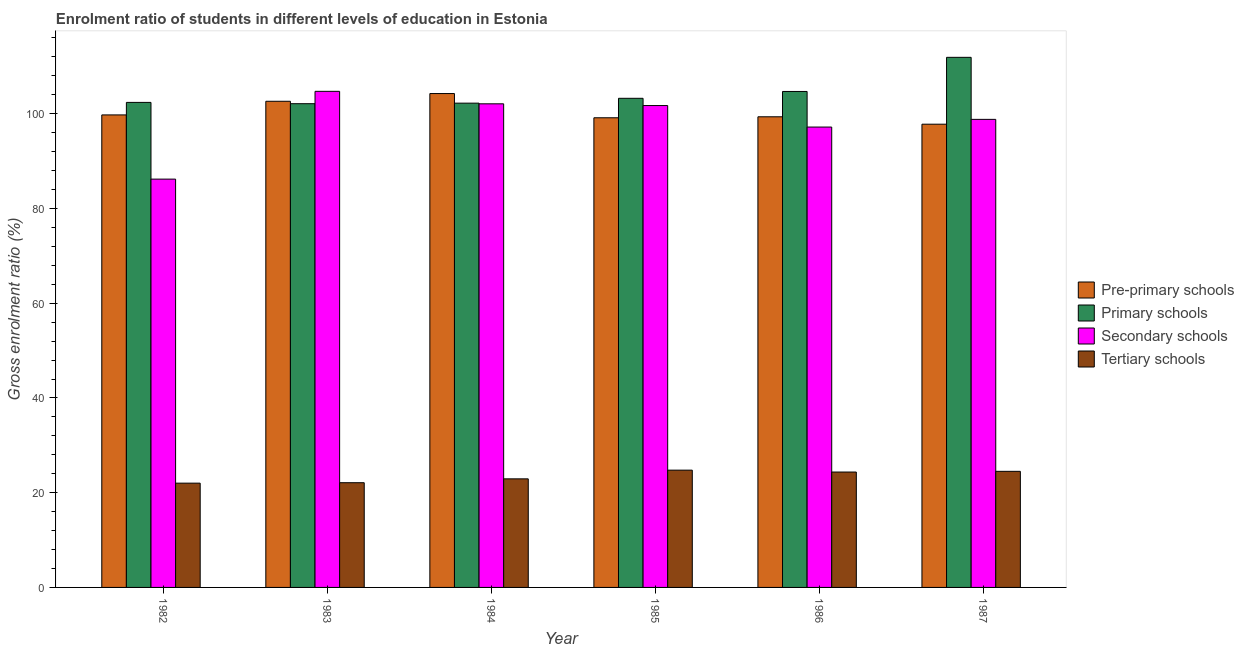Are the number of bars on each tick of the X-axis equal?
Provide a short and direct response. Yes. How many bars are there on the 5th tick from the left?
Offer a very short reply. 4. How many bars are there on the 1st tick from the right?
Your response must be concise. 4. In how many cases, is the number of bars for a given year not equal to the number of legend labels?
Offer a very short reply. 0. What is the gross enrolment ratio in tertiary schools in 1985?
Your answer should be very brief. 24.76. Across all years, what is the maximum gross enrolment ratio in primary schools?
Your response must be concise. 111.91. Across all years, what is the minimum gross enrolment ratio in primary schools?
Ensure brevity in your answer.  102.12. What is the total gross enrolment ratio in tertiary schools in the graph?
Provide a succinct answer. 140.67. What is the difference between the gross enrolment ratio in pre-primary schools in 1983 and that in 1986?
Your answer should be very brief. 3.27. What is the difference between the gross enrolment ratio in pre-primary schools in 1985 and the gross enrolment ratio in secondary schools in 1982?
Your answer should be very brief. -0.6. What is the average gross enrolment ratio in primary schools per year?
Make the answer very short. 104.44. In the year 1983, what is the difference between the gross enrolment ratio in tertiary schools and gross enrolment ratio in secondary schools?
Provide a short and direct response. 0. In how many years, is the gross enrolment ratio in pre-primary schools greater than 8 %?
Your answer should be compact. 6. What is the ratio of the gross enrolment ratio in primary schools in 1986 to that in 1987?
Ensure brevity in your answer.  0.94. Is the gross enrolment ratio in tertiary schools in 1983 less than that in 1985?
Offer a terse response. Yes. Is the difference between the gross enrolment ratio in primary schools in 1982 and 1983 greater than the difference between the gross enrolment ratio in pre-primary schools in 1982 and 1983?
Your answer should be compact. No. What is the difference between the highest and the second highest gross enrolment ratio in pre-primary schools?
Offer a very short reply. 1.63. What is the difference between the highest and the lowest gross enrolment ratio in secondary schools?
Offer a terse response. 18.53. Is the sum of the gross enrolment ratio in primary schools in 1984 and 1985 greater than the maximum gross enrolment ratio in tertiary schools across all years?
Your response must be concise. Yes. Is it the case that in every year, the sum of the gross enrolment ratio in secondary schools and gross enrolment ratio in tertiary schools is greater than the sum of gross enrolment ratio in pre-primary schools and gross enrolment ratio in primary schools?
Provide a short and direct response. No. What does the 4th bar from the left in 1983 represents?
Offer a terse response. Tertiary schools. What does the 4th bar from the right in 1983 represents?
Provide a short and direct response. Pre-primary schools. Is it the case that in every year, the sum of the gross enrolment ratio in pre-primary schools and gross enrolment ratio in primary schools is greater than the gross enrolment ratio in secondary schools?
Provide a succinct answer. Yes. How many bars are there?
Ensure brevity in your answer.  24. How many years are there in the graph?
Offer a very short reply. 6. What is the difference between two consecutive major ticks on the Y-axis?
Your response must be concise. 20. Are the values on the major ticks of Y-axis written in scientific E-notation?
Your answer should be compact. No. Does the graph contain grids?
Offer a very short reply. No. What is the title of the graph?
Ensure brevity in your answer.  Enrolment ratio of students in different levels of education in Estonia. What is the Gross enrolment ratio (%) of Pre-primary schools in 1982?
Offer a very short reply. 99.75. What is the Gross enrolment ratio (%) in Primary schools in 1982?
Provide a short and direct response. 102.39. What is the Gross enrolment ratio (%) of Secondary schools in 1982?
Give a very brief answer. 86.2. What is the Gross enrolment ratio (%) in Tertiary schools in 1982?
Your answer should be very brief. 22.01. What is the Gross enrolment ratio (%) in Pre-primary schools in 1983?
Ensure brevity in your answer.  102.63. What is the Gross enrolment ratio (%) in Primary schools in 1983?
Give a very brief answer. 102.12. What is the Gross enrolment ratio (%) of Secondary schools in 1983?
Provide a short and direct response. 104.73. What is the Gross enrolment ratio (%) in Tertiary schools in 1983?
Make the answer very short. 22.11. What is the Gross enrolment ratio (%) in Pre-primary schools in 1984?
Your answer should be very brief. 104.26. What is the Gross enrolment ratio (%) in Primary schools in 1984?
Offer a terse response. 102.24. What is the Gross enrolment ratio (%) in Secondary schools in 1984?
Offer a terse response. 102.1. What is the Gross enrolment ratio (%) of Tertiary schools in 1984?
Offer a very short reply. 22.92. What is the Gross enrolment ratio (%) in Pre-primary schools in 1985?
Provide a short and direct response. 99.15. What is the Gross enrolment ratio (%) in Primary schools in 1985?
Provide a short and direct response. 103.26. What is the Gross enrolment ratio (%) of Secondary schools in 1985?
Make the answer very short. 101.73. What is the Gross enrolment ratio (%) in Tertiary schools in 1985?
Your answer should be very brief. 24.76. What is the Gross enrolment ratio (%) in Pre-primary schools in 1986?
Offer a terse response. 99.36. What is the Gross enrolment ratio (%) of Primary schools in 1986?
Your response must be concise. 104.7. What is the Gross enrolment ratio (%) in Secondary schools in 1986?
Offer a very short reply. 97.19. What is the Gross enrolment ratio (%) of Tertiary schools in 1986?
Offer a terse response. 24.36. What is the Gross enrolment ratio (%) in Pre-primary schools in 1987?
Offer a very short reply. 97.79. What is the Gross enrolment ratio (%) of Primary schools in 1987?
Keep it short and to the point. 111.91. What is the Gross enrolment ratio (%) in Secondary schools in 1987?
Your response must be concise. 98.81. What is the Gross enrolment ratio (%) of Tertiary schools in 1987?
Keep it short and to the point. 24.51. Across all years, what is the maximum Gross enrolment ratio (%) of Pre-primary schools?
Your answer should be compact. 104.26. Across all years, what is the maximum Gross enrolment ratio (%) of Primary schools?
Make the answer very short. 111.91. Across all years, what is the maximum Gross enrolment ratio (%) of Secondary schools?
Keep it short and to the point. 104.73. Across all years, what is the maximum Gross enrolment ratio (%) of Tertiary schools?
Provide a short and direct response. 24.76. Across all years, what is the minimum Gross enrolment ratio (%) of Pre-primary schools?
Give a very brief answer. 97.79. Across all years, what is the minimum Gross enrolment ratio (%) in Primary schools?
Provide a succinct answer. 102.12. Across all years, what is the minimum Gross enrolment ratio (%) of Secondary schools?
Your answer should be very brief. 86.2. Across all years, what is the minimum Gross enrolment ratio (%) of Tertiary schools?
Give a very brief answer. 22.01. What is the total Gross enrolment ratio (%) in Pre-primary schools in the graph?
Make the answer very short. 602.95. What is the total Gross enrolment ratio (%) in Primary schools in the graph?
Provide a succinct answer. 626.62. What is the total Gross enrolment ratio (%) of Secondary schools in the graph?
Make the answer very short. 590.75. What is the total Gross enrolment ratio (%) in Tertiary schools in the graph?
Ensure brevity in your answer.  140.67. What is the difference between the Gross enrolment ratio (%) of Pre-primary schools in 1982 and that in 1983?
Ensure brevity in your answer.  -2.88. What is the difference between the Gross enrolment ratio (%) in Primary schools in 1982 and that in 1983?
Your response must be concise. 0.28. What is the difference between the Gross enrolment ratio (%) of Secondary schools in 1982 and that in 1983?
Your response must be concise. -18.53. What is the difference between the Gross enrolment ratio (%) of Tertiary schools in 1982 and that in 1983?
Your response must be concise. -0.09. What is the difference between the Gross enrolment ratio (%) of Pre-primary schools in 1982 and that in 1984?
Ensure brevity in your answer.  -4.51. What is the difference between the Gross enrolment ratio (%) of Primary schools in 1982 and that in 1984?
Keep it short and to the point. 0.16. What is the difference between the Gross enrolment ratio (%) in Secondary schools in 1982 and that in 1984?
Offer a terse response. -15.9. What is the difference between the Gross enrolment ratio (%) of Tertiary schools in 1982 and that in 1984?
Offer a very short reply. -0.91. What is the difference between the Gross enrolment ratio (%) in Pre-primary schools in 1982 and that in 1985?
Provide a succinct answer. 0.6. What is the difference between the Gross enrolment ratio (%) of Primary schools in 1982 and that in 1985?
Keep it short and to the point. -0.87. What is the difference between the Gross enrolment ratio (%) of Secondary schools in 1982 and that in 1985?
Your answer should be compact. -15.53. What is the difference between the Gross enrolment ratio (%) of Tertiary schools in 1982 and that in 1985?
Offer a terse response. -2.75. What is the difference between the Gross enrolment ratio (%) in Pre-primary schools in 1982 and that in 1986?
Your answer should be very brief. 0.4. What is the difference between the Gross enrolment ratio (%) in Primary schools in 1982 and that in 1986?
Give a very brief answer. -2.31. What is the difference between the Gross enrolment ratio (%) of Secondary schools in 1982 and that in 1986?
Keep it short and to the point. -10.99. What is the difference between the Gross enrolment ratio (%) of Tertiary schools in 1982 and that in 1986?
Provide a succinct answer. -2.35. What is the difference between the Gross enrolment ratio (%) of Pre-primary schools in 1982 and that in 1987?
Make the answer very short. 1.96. What is the difference between the Gross enrolment ratio (%) of Primary schools in 1982 and that in 1987?
Your answer should be very brief. -9.51. What is the difference between the Gross enrolment ratio (%) in Secondary schools in 1982 and that in 1987?
Keep it short and to the point. -12.61. What is the difference between the Gross enrolment ratio (%) of Tertiary schools in 1982 and that in 1987?
Give a very brief answer. -2.49. What is the difference between the Gross enrolment ratio (%) of Pre-primary schools in 1983 and that in 1984?
Keep it short and to the point. -1.63. What is the difference between the Gross enrolment ratio (%) in Primary schools in 1983 and that in 1984?
Give a very brief answer. -0.12. What is the difference between the Gross enrolment ratio (%) in Secondary schools in 1983 and that in 1984?
Provide a succinct answer. 2.63. What is the difference between the Gross enrolment ratio (%) of Tertiary schools in 1983 and that in 1984?
Offer a very short reply. -0.81. What is the difference between the Gross enrolment ratio (%) of Pre-primary schools in 1983 and that in 1985?
Your answer should be compact. 3.48. What is the difference between the Gross enrolment ratio (%) of Primary schools in 1983 and that in 1985?
Your answer should be compact. -1.14. What is the difference between the Gross enrolment ratio (%) in Secondary schools in 1983 and that in 1985?
Offer a very short reply. 3. What is the difference between the Gross enrolment ratio (%) in Tertiary schools in 1983 and that in 1985?
Offer a very short reply. -2.65. What is the difference between the Gross enrolment ratio (%) of Pre-primary schools in 1983 and that in 1986?
Give a very brief answer. 3.27. What is the difference between the Gross enrolment ratio (%) of Primary schools in 1983 and that in 1986?
Provide a short and direct response. -2.58. What is the difference between the Gross enrolment ratio (%) of Secondary schools in 1983 and that in 1986?
Keep it short and to the point. 7.54. What is the difference between the Gross enrolment ratio (%) in Tertiary schools in 1983 and that in 1986?
Ensure brevity in your answer.  -2.25. What is the difference between the Gross enrolment ratio (%) in Pre-primary schools in 1983 and that in 1987?
Keep it short and to the point. 4.84. What is the difference between the Gross enrolment ratio (%) in Primary schools in 1983 and that in 1987?
Ensure brevity in your answer.  -9.79. What is the difference between the Gross enrolment ratio (%) of Secondary schools in 1983 and that in 1987?
Keep it short and to the point. 5.92. What is the difference between the Gross enrolment ratio (%) in Tertiary schools in 1983 and that in 1987?
Offer a very short reply. -2.4. What is the difference between the Gross enrolment ratio (%) in Pre-primary schools in 1984 and that in 1985?
Keep it short and to the point. 5.11. What is the difference between the Gross enrolment ratio (%) of Primary schools in 1984 and that in 1985?
Provide a succinct answer. -1.02. What is the difference between the Gross enrolment ratio (%) of Secondary schools in 1984 and that in 1985?
Your response must be concise. 0.37. What is the difference between the Gross enrolment ratio (%) in Tertiary schools in 1984 and that in 1985?
Ensure brevity in your answer.  -1.84. What is the difference between the Gross enrolment ratio (%) in Pre-primary schools in 1984 and that in 1986?
Make the answer very short. 4.9. What is the difference between the Gross enrolment ratio (%) of Primary schools in 1984 and that in 1986?
Make the answer very short. -2.47. What is the difference between the Gross enrolment ratio (%) of Secondary schools in 1984 and that in 1986?
Ensure brevity in your answer.  4.91. What is the difference between the Gross enrolment ratio (%) in Tertiary schools in 1984 and that in 1986?
Offer a terse response. -1.44. What is the difference between the Gross enrolment ratio (%) of Pre-primary schools in 1984 and that in 1987?
Your answer should be very brief. 6.47. What is the difference between the Gross enrolment ratio (%) of Primary schools in 1984 and that in 1987?
Make the answer very short. -9.67. What is the difference between the Gross enrolment ratio (%) in Secondary schools in 1984 and that in 1987?
Your response must be concise. 3.28. What is the difference between the Gross enrolment ratio (%) in Tertiary schools in 1984 and that in 1987?
Keep it short and to the point. -1.58. What is the difference between the Gross enrolment ratio (%) of Pre-primary schools in 1985 and that in 1986?
Your answer should be compact. -0.21. What is the difference between the Gross enrolment ratio (%) in Primary schools in 1985 and that in 1986?
Offer a terse response. -1.44. What is the difference between the Gross enrolment ratio (%) of Secondary schools in 1985 and that in 1986?
Make the answer very short. 4.54. What is the difference between the Gross enrolment ratio (%) in Tertiary schools in 1985 and that in 1986?
Ensure brevity in your answer.  0.4. What is the difference between the Gross enrolment ratio (%) in Pre-primary schools in 1985 and that in 1987?
Give a very brief answer. 1.36. What is the difference between the Gross enrolment ratio (%) in Primary schools in 1985 and that in 1987?
Provide a short and direct response. -8.65. What is the difference between the Gross enrolment ratio (%) in Secondary schools in 1985 and that in 1987?
Ensure brevity in your answer.  2.92. What is the difference between the Gross enrolment ratio (%) of Tertiary schools in 1985 and that in 1987?
Your answer should be compact. 0.25. What is the difference between the Gross enrolment ratio (%) in Pre-primary schools in 1986 and that in 1987?
Your response must be concise. 1.56. What is the difference between the Gross enrolment ratio (%) in Primary schools in 1986 and that in 1987?
Your response must be concise. -7.21. What is the difference between the Gross enrolment ratio (%) of Secondary schools in 1986 and that in 1987?
Provide a succinct answer. -1.62. What is the difference between the Gross enrolment ratio (%) in Tertiary schools in 1986 and that in 1987?
Offer a terse response. -0.15. What is the difference between the Gross enrolment ratio (%) of Pre-primary schools in 1982 and the Gross enrolment ratio (%) of Primary schools in 1983?
Ensure brevity in your answer.  -2.37. What is the difference between the Gross enrolment ratio (%) of Pre-primary schools in 1982 and the Gross enrolment ratio (%) of Secondary schools in 1983?
Your answer should be very brief. -4.98. What is the difference between the Gross enrolment ratio (%) in Pre-primary schools in 1982 and the Gross enrolment ratio (%) in Tertiary schools in 1983?
Your answer should be very brief. 77.65. What is the difference between the Gross enrolment ratio (%) of Primary schools in 1982 and the Gross enrolment ratio (%) of Secondary schools in 1983?
Offer a terse response. -2.34. What is the difference between the Gross enrolment ratio (%) of Primary schools in 1982 and the Gross enrolment ratio (%) of Tertiary schools in 1983?
Your response must be concise. 80.29. What is the difference between the Gross enrolment ratio (%) in Secondary schools in 1982 and the Gross enrolment ratio (%) in Tertiary schools in 1983?
Provide a short and direct response. 64.09. What is the difference between the Gross enrolment ratio (%) of Pre-primary schools in 1982 and the Gross enrolment ratio (%) of Primary schools in 1984?
Provide a succinct answer. -2.48. What is the difference between the Gross enrolment ratio (%) of Pre-primary schools in 1982 and the Gross enrolment ratio (%) of Secondary schools in 1984?
Keep it short and to the point. -2.34. What is the difference between the Gross enrolment ratio (%) in Pre-primary schools in 1982 and the Gross enrolment ratio (%) in Tertiary schools in 1984?
Your answer should be very brief. 76.83. What is the difference between the Gross enrolment ratio (%) in Primary schools in 1982 and the Gross enrolment ratio (%) in Secondary schools in 1984?
Offer a very short reply. 0.3. What is the difference between the Gross enrolment ratio (%) of Primary schools in 1982 and the Gross enrolment ratio (%) of Tertiary schools in 1984?
Make the answer very short. 79.47. What is the difference between the Gross enrolment ratio (%) of Secondary schools in 1982 and the Gross enrolment ratio (%) of Tertiary schools in 1984?
Provide a short and direct response. 63.27. What is the difference between the Gross enrolment ratio (%) in Pre-primary schools in 1982 and the Gross enrolment ratio (%) in Primary schools in 1985?
Give a very brief answer. -3.51. What is the difference between the Gross enrolment ratio (%) in Pre-primary schools in 1982 and the Gross enrolment ratio (%) in Secondary schools in 1985?
Provide a succinct answer. -1.97. What is the difference between the Gross enrolment ratio (%) in Pre-primary schools in 1982 and the Gross enrolment ratio (%) in Tertiary schools in 1985?
Ensure brevity in your answer.  74.99. What is the difference between the Gross enrolment ratio (%) in Primary schools in 1982 and the Gross enrolment ratio (%) in Secondary schools in 1985?
Your answer should be compact. 0.67. What is the difference between the Gross enrolment ratio (%) in Primary schools in 1982 and the Gross enrolment ratio (%) in Tertiary schools in 1985?
Give a very brief answer. 77.63. What is the difference between the Gross enrolment ratio (%) of Secondary schools in 1982 and the Gross enrolment ratio (%) of Tertiary schools in 1985?
Offer a very short reply. 61.44. What is the difference between the Gross enrolment ratio (%) of Pre-primary schools in 1982 and the Gross enrolment ratio (%) of Primary schools in 1986?
Provide a short and direct response. -4.95. What is the difference between the Gross enrolment ratio (%) of Pre-primary schools in 1982 and the Gross enrolment ratio (%) of Secondary schools in 1986?
Ensure brevity in your answer.  2.56. What is the difference between the Gross enrolment ratio (%) of Pre-primary schools in 1982 and the Gross enrolment ratio (%) of Tertiary schools in 1986?
Provide a short and direct response. 75.39. What is the difference between the Gross enrolment ratio (%) in Primary schools in 1982 and the Gross enrolment ratio (%) in Secondary schools in 1986?
Keep it short and to the point. 5.2. What is the difference between the Gross enrolment ratio (%) in Primary schools in 1982 and the Gross enrolment ratio (%) in Tertiary schools in 1986?
Your answer should be compact. 78.04. What is the difference between the Gross enrolment ratio (%) of Secondary schools in 1982 and the Gross enrolment ratio (%) of Tertiary schools in 1986?
Your answer should be very brief. 61.84. What is the difference between the Gross enrolment ratio (%) in Pre-primary schools in 1982 and the Gross enrolment ratio (%) in Primary schools in 1987?
Your response must be concise. -12.16. What is the difference between the Gross enrolment ratio (%) in Pre-primary schools in 1982 and the Gross enrolment ratio (%) in Secondary schools in 1987?
Offer a very short reply. 0.94. What is the difference between the Gross enrolment ratio (%) in Pre-primary schools in 1982 and the Gross enrolment ratio (%) in Tertiary schools in 1987?
Make the answer very short. 75.25. What is the difference between the Gross enrolment ratio (%) in Primary schools in 1982 and the Gross enrolment ratio (%) in Secondary schools in 1987?
Keep it short and to the point. 3.58. What is the difference between the Gross enrolment ratio (%) of Primary schools in 1982 and the Gross enrolment ratio (%) of Tertiary schools in 1987?
Offer a very short reply. 77.89. What is the difference between the Gross enrolment ratio (%) in Secondary schools in 1982 and the Gross enrolment ratio (%) in Tertiary schools in 1987?
Your answer should be compact. 61.69. What is the difference between the Gross enrolment ratio (%) of Pre-primary schools in 1983 and the Gross enrolment ratio (%) of Primary schools in 1984?
Ensure brevity in your answer.  0.4. What is the difference between the Gross enrolment ratio (%) of Pre-primary schools in 1983 and the Gross enrolment ratio (%) of Secondary schools in 1984?
Your answer should be very brief. 0.54. What is the difference between the Gross enrolment ratio (%) in Pre-primary schools in 1983 and the Gross enrolment ratio (%) in Tertiary schools in 1984?
Ensure brevity in your answer.  79.71. What is the difference between the Gross enrolment ratio (%) in Primary schools in 1983 and the Gross enrolment ratio (%) in Secondary schools in 1984?
Provide a succinct answer. 0.02. What is the difference between the Gross enrolment ratio (%) of Primary schools in 1983 and the Gross enrolment ratio (%) of Tertiary schools in 1984?
Give a very brief answer. 79.2. What is the difference between the Gross enrolment ratio (%) of Secondary schools in 1983 and the Gross enrolment ratio (%) of Tertiary schools in 1984?
Make the answer very short. 81.81. What is the difference between the Gross enrolment ratio (%) of Pre-primary schools in 1983 and the Gross enrolment ratio (%) of Primary schools in 1985?
Make the answer very short. -0.63. What is the difference between the Gross enrolment ratio (%) in Pre-primary schools in 1983 and the Gross enrolment ratio (%) in Secondary schools in 1985?
Provide a short and direct response. 0.9. What is the difference between the Gross enrolment ratio (%) in Pre-primary schools in 1983 and the Gross enrolment ratio (%) in Tertiary schools in 1985?
Your answer should be very brief. 77.87. What is the difference between the Gross enrolment ratio (%) of Primary schools in 1983 and the Gross enrolment ratio (%) of Secondary schools in 1985?
Offer a very short reply. 0.39. What is the difference between the Gross enrolment ratio (%) in Primary schools in 1983 and the Gross enrolment ratio (%) in Tertiary schools in 1985?
Provide a short and direct response. 77.36. What is the difference between the Gross enrolment ratio (%) in Secondary schools in 1983 and the Gross enrolment ratio (%) in Tertiary schools in 1985?
Keep it short and to the point. 79.97. What is the difference between the Gross enrolment ratio (%) in Pre-primary schools in 1983 and the Gross enrolment ratio (%) in Primary schools in 1986?
Your answer should be compact. -2.07. What is the difference between the Gross enrolment ratio (%) in Pre-primary schools in 1983 and the Gross enrolment ratio (%) in Secondary schools in 1986?
Keep it short and to the point. 5.44. What is the difference between the Gross enrolment ratio (%) of Pre-primary schools in 1983 and the Gross enrolment ratio (%) of Tertiary schools in 1986?
Give a very brief answer. 78.27. What is the difference between the Gross enrolment ratio (%) of Primary schools in 1983 and the Gross enrolment ratio (%) of Secondary schools in 1986?
Ensure brevity in your answer.  4.93. What is the difference between the Gross enrolment ratio (%) of Primary schools in 1983 and the Gross enrolment ratio (%) of Tertiary schools in 1986?
Keep it short and to the point. 77.76. What is the difference between the Gross enrolment ratio (%) in Secondary schools in 1983 and the Gross enrolment ratio (%) in Tertiary schools in 1986?
Your answer should be very brief. 80.37. What is the difference between the Gross enrolment ratio (%) in Pre-primary schools in 1983 and the Gross enrolment ratio (%) in Primary schools in 1987?
Provide a succinct answer. -9.28. What is the difference between the Gross enrolment ratio (%) in Pre-primary schools in 1983 and the Gross enrolment ratio (%) in Secondary schools in 1987?
Offer a very short reply. 3.82. What is the difference between the Gross enrolment ratio (%) in Pre-primary schools in 1983 and the Gross enrolment ratio (%) in Tertiary schools in 1987?
Offer a very short reply. 78.12. What is the difference between the Gross enrolment ratio (%) in Primary schools in 1983 and the Gross enrolment ratio (%) in Secondary schools in 1987?
Keep it short and to the point. 3.31. What is the difference between the Gross enrolment ratio (%) of Primary schools in 1983 and the Gross enrolment ratio (%) of Tertiary schools in 1987?
Your response must be concise. 77.61. What is the difference between the Gross enrolment ratio (%) of Secondary schools in 1983 and the Gross enrolment ratio (%) of Tertiary schools in 1987?
Your answer should be very brief. 80.22. What is the difference between the Gross enrolment ratio (%) in Pre-primary schools in 1984 and the Gross enrolment ratio (%) in Primary schools in 1985?
Provide a succinct answer. 1. What is the difference between the Gross enrolment ratio (%) of Pre-primary schools in 1984 and the Gross enrolment ratio (%) of Secondary schools in 1985?
Your answer should be very brief. 2.53. What is the difference between the Gross enrolment ratio (%) of Pre-primary schools in 1984 and the Gross enrolment ratio (%) of Tertiary schools in 1985?
Provide a short and direct response. 79.5. What is the difference between the Gross enrolment ratio (%) in Primary schools in 1984 and the Gross enrolment ratio (%) in Secondary schools in 1985?
Offer a terse response. 0.51. What is the difference between the Gross enrolment ratio (%) in Primary schools in 1984 and the Gross enrolment ratio (%) in Tertiary schools in 1985?
Offer a terse response. 77.48. What is the difference between the Gross enrolment ratio (%) of Secondary schools in 1984 and the Gross enrolment ratio (%) of Tertiary schools in 1985?
Give a very brief answer. 77.34. What is the difference between the Gross enrolment ratio (%) in Pre-primary schools in 1984 and the Gross enrolment ratio (%) in Primary schools in 1986?
Make the answer very short. -0.44. What is the difference between the Gross enrolment ratio (%) in Pre-primary schools in 1984 and the Gross enrolment ratio (%) in Secondary schools in 1986?
Give a very brief answer. 7.07. What is the difference between the Gross enrolment ratio (%) of Pre-primary schools in 1984 and the Gross enrolment ratio (%) of Tertiary schools in 1986?
Your answer should be very brief. 79.9. What is the difference between the Gross enrolment ratio (%) in Primary schools in 1984 and the Gross enrolment ratio (%) in Secondary schools in 1986?
Your response must be concise. 5.04. What is the difference between the Gross enrolment ratio (%) of Primary schools in 1984 and the Gross enrolment ratio (%) of Tertiary schools in 1986?
Provide a succinct answer. 77.88. What is the difference between the Gross enrolment ratio (%) of Secondary schools in 1984 and the Gross enrolment ratio (%) of Tertiary schools in 1986?
Offer a very short reply. 77.74. What is the difference between the Gross enrolment ratio (%) of Pre-primary schools in 1984 and the Gross enrolment ratio (%) of Primary schools in 1987?
Your response must be concise. -7.65. What is the difference between the Gross enrolment ratio (%) in Pre-primary schools in 1984 and the Gross enrolment ratio (%) in Secondary schools in 1987?
Offer a terse response. 5.45. What is the difference between the Gross enrolment ratio (%) in Pre-primary schools in 1984 and the Gross enrolment ratio (%) in Tertiary schools in 1987?
Offer a very short reply. 79.75. What is the difference between the Gross enrolment ratio (%) in Primary schools in 1984 and the Gross enrolment ratio (%) in Secondary schools in 1987?
Provide a succinct answer. 3.42. What is the difference between the Gross enrolment ratio (%) of Primary schools in 1984 and the Gross enrolment ratio (%) of Tertiary schools in 1987?
Keep it short and to the point. 77.73. What is the difference between the Gross enrolment ratio (%) of Secondary schools in 1984 and the Gross enrolment ratio (%) of Tertiary schools in 1987?
Your response must be concise. 77.59. What is the difference between the Gross enrolment ratio (%) of Pre-primary schools in 1985 and the Gross enrolment ratio (%) of Primary schools in 1986?
Give a very brief answer. -5.55. What is the difference between the Gross enrolment ratio (%) in Pre-primary schools in 1985 and the Gross enrolment ratio (%) in Secondary schools in 1986?
Make the answer very short. 1.96. What is the difference between the Gross enrolment ratio (%) of Pre-primary schools in 1985 and the Gross enrolment ratio (%) of Tertiary schools in 1986?
Your answer should be compact. 74.79. What is the difference between the Gross enrolment ratio (%) of Primary schools in 1985 and the Gross enrolment ratio (%) of Secondary schools in 1986?
Ensure brevity in your answer.  6.07. What is the difference between the Gross enrolment ratio (%) of Primary schools in 1985 and the Gross enrolment ratio (%) of Tertiary schools in 1986?
Provide a short and direct response. 78.9. What is the difference between the Gross enrolment ratio (%) in Secondary schools in 1985 and the Gross enrolment ratio (%) in Tertiary schools in 1986?
Your answer should be very brief. 77.37. What is the difference between the Gross enrolment ratio (%) of Pre-primary schools in 1985 and the Gross enrolment ratio (%) of Primary schools in 1987?
Offer a very short reply. -12.76. What is the difference between the Gross enrolment ratio (%) in Pre-primary schools in 1985 and the Gross enrolment ratio (%) in Secondary schools in 1987?
Offer a very short reply. 0.34. What is the difference between the Gross enrolment ratio (%) in Pre-primary schools in 1985 and the Gross enrolment ratio (%) in Tertiary schools in 1987?
Your answer should be very brief. 74.64. What is the difference between the Gross enrolment ratio (%) in Primary schools in 1985 and the Gross enrolment ratio (%) in Secondary schools in 1987?
Provide a short and direct response. 4.45. What is the difference between the Gross enrolment ratio (%) in Primary schools in 1985 and the Gross enrolment ratio (%) in Tertiary schools in 1987?
Provide a short and direct response. 78.75. What is the difference between the Gross enrolment ratio (%) of Secondary schools in 1985 and the Gross enrolment ratio (%) of Tertiary schools in 1987?
Provide a short and direct response. 77.22. What is the difference between the Gross enrolment ratio (%) in Pre-primary schools in 1986 and the Gross enrolment ratio (%) in Primary schools in 1987?
Your answer should be very brief. -12.55. What is the difference between the Gross enrolment ratio (%) in Pre-primary schools in 1986 and the Gross enrolment ratio (%) in Secondary schools in 1987?
Offer a terse response. 0.55. What is the difference between the Gross enrolment ratio (%) in Pre-primary schools in 1986 and the Gross enrolment ratio (%) in Tertiary schools in 1987?
Offer a terse response. 74.85. What is the difference between the Gross enrolment ratio (%) in Primary schools in 1986 and the Gross enrolment ratio (%) in Secondary schools in 1987?
Provide a succinct answer. 5.89. What is the difference between the Gross enrolment ratio (%) in Primary schools in 1986 and the Gross enrolment ratio (%) in Tertiary schools in 1987?
Your response must be concise. 80.2. What is the difference between the Gross enrolment ratio (%) of Secondary schools in 1986 and the Gross enrolment ratio (%) of Tertiary schools in 1987?
Ensure brevity in your answer.  72.68. What is the average Gross enrolment ratio (%) of Pre-primary schools per year?
Provide a short and direct response. 100.49. What is the average Gross enrolment ratio (%) in Primary schools per year?
Your answer should be compact. 104.44. What is the average Gross enrolment ratio (%) of Secondary schools per year?
Your answer should be compact. 98.46. What is the average Gross enrolment ratio (%) in Tertiary schools per year?
Offer a terse response. 23.44. In the year 1982, what is the difference between the Gross enrolment ratio (%) of Pre-primary schools and Gross enrolment ratio (%) of Primary schools?
Make the answer very short. -2.64. In the year 1982, what is the difference between the Gross enrolment ratio (%) of Pre-primary schools and Gross enrolment ratio (%) of Secondary schools?
Ensure brevity in your answer.  13.56. In the year 1982, what is the difference between the Gross enrolment ratio (%) in Pre-primary schools and Gross enrolment ratio (%) in Tertiary schools?
Your response must be concise. 77.74. In the year 1982, what is the difference between the Gross enrolment ratio (%) in Primary schools and Gross enrolment ratio (%) in Secondary schools?
Offer a terse response. 16.2. In the year 1982, what is the difference between the Gross enrolment ratio (%) in Primary schools and Gross enrolment ratio (%) in Tertiary schools?
Your response must be concise. 80.38. In the year 1982, what is the difference between the Gross enrolment ratio (%) in Secondary schools and Gross enrolment ratio (%) in Tertiary schools?
Offer a very short reply. 64.18. In the year 1983, what is the difference between the Gross enrolment ratio (%) in Pre-primary schools and Gross enrolment ratio (%) in Primary schools?
Provide a short and direct response. 0.51. In the year 1983, what is the difference between the Gross enrolment ratio (%) in Pre-primary schools and Gross enrolment ratio (%) in Secondary schools?
Give a very brief answer. -2.1. In the year 1983, what is the difference between the Gross enrolment ratio (%) of Pre-primary schools and Gross enrolment ratio (%) of Tertiary schools?
Your answer should be very brief. 80.52. In the year 1983, what is the difference between the Gross enrolment ratio (%) of Primary schools and Gross enrolment ratio (%) of Secondary schools?
Your answer should be compact. -2.61. In the year 1983, what is the difference between the Gross enrolment ratio (%) of Primary schools and Gross enrolment ratio (%) of Tertiary schools?
Your answer should be very brief. 80.01. In the year 1983, what is the difference between the Gross enrolment ratio (%) in Secondary schools and Gross enrolment ratio (%) in Tertiary schools?
Give a very brief answer. 82.62. In the year 1984, what is the difference between the Gross enrolment ratio (%) of Pre-primary schools and Gross enrolment ratio (%) of Primary schools?
Offer a very short reply. 2.02. In the year 1984, what is the difference between the Gross enrolment ratio (%) of Pre-primary schools and Gross enrolment ratio (%) of Secondary schools?
Keep it short and to the point. 2.16. In the year 1984, what is the difference between the Gross enrolment ratio (%) of Pre-primary schools and Gross enrolment ratio (%) of Tertiary schools?
Your response must be concise. 81.34. In the year 1984, what is the difference between the Gross enrolment ratio (%) of Primary schools and Gross enrolment ratio (%) of Secondary schools?
Ensure brevity in your answer.  0.14. In the year 1984, what is the difference between the Gross enrolment ratio (%) in Primary schools and Gross enrolment ratio (%) in Tertiary schools?
Offer a terse response. 79.31. In the year 1984, what is the difference between the Gross enrolment ratio (%) in Secondary schools and Gross enrolment ratio (%) in Tertiary schools?
Provide a succinct answer. 79.17. In the year 1985, what is the difference between the Gross enrolment ratio (%) in Pre-primary schools and Gross enrolment ratio (%) in Primary schools?
Make the answer very short. -4.11. In the year 1985, what is the difference between the Gross enrolment ratio (%) in Pre-primary schools and Gross enrolment ratio (%) in Secondary schools?
Your response must be concise. -2.58. In the year 1985, what is the difference between the Gross enrolment ratio (%) in Pre-primary schools and Gross enrolment ratio (%) in Tertiary schools?
Keep it short and to the point. 74.39. In the year 1985, what is the difference between the Gross enrolment ratio (%) in Primary schools and Gross enrolment ratio (%) in Secondary schools?
Give a very brief answer. 1.53. In the year 1985, what is the difference between the Gross enrolment ratio (%) of Primary schools and Gross enrolment ratio (%) of Tertiary schools?
Ensure brevity in your answer.  78.5. In the year 1985, what is the difference between the Gross enrolment ratio (%) in Secondary schools and Gross enrolment ratio (%) in Tertiary schools?
Make the answer very short. 76.97. In the year 1986, what is the difference between the Gross enrolment ratio (%) of Pre-primary schools and Gross enrolment ratio (%) of Primary schools?
Provide a succinct answer. -5.35. In the year 1986, what is the difference between the Gross enrolment ratio (%) of Pre-primary schools and Gross enrolment ratio (%) of Secondary schools?
Your answer should be very brief. 2.17. In the year 1986, what is the difference between the Gross enrolment ratio (%) of Pre-primary schools and Gross enrolment ratio (%) of Tertiary schools?
Offer a terse response. 75. In the year 1986, what is the difference between the Gross enrolment ratio (%) of Primary schools and Gross enrolment ratio (%) of Secondary schools?
Give a very brief answer. 7.51. In the year 1986, what is the difference between the Gross enrolment ratio (%) of Primary schools and Gross enrolment ratio (%) of Tertiary schools?
Ensure brevity in your answer.  80.34. In the year 1986, what is the difference between the Gross enrolment ratio (%) in Secondary schools and Gross enrolment ratio (%) in Tertiary schools?
Ensure brevity in your answer.  72.83. In the year 1987, what is the difference between the Gross enrolment ratio (%) of Pre-primary schools and Gross enrolment ratio (%) of Primary schools?
Your answer should be compact. -14.12. In the year 1987, what is the difference between the Gross enrolment ratio (%) of Pre-primary schools and Gross enrolment ratio (%) of Secondary schools?
Your response must be concise. -1.02. In the year 1987, what is the difference between the Gross enrolment ratio (%) of Pre-primary schools and Gross enrolment ratio (%) of Tertiary schools?
Offer a very short reply. 73.29. In the year 1987, what is the difference between the Gross enrolment ratio (%) in Primary schools and Gross enrolment ratio (%) in Secondary schools?
Give a very brief answer. 13.1. In the year 1987, what is the difference between the Gross enrolment ratio (%) of Primary schools and Gross enrolment ratio (%) of Tertiary schools?
Keep it short and to the point. 87.4. In the year 1987, what is the difference between the Gross enrolment ratio (%) of Secondary schools and Gross enrolment ratio (%) of Tertiary schools?
Your answer should be compact. 74.31. What is the ratio of the Gross enrolment ratio (%) in Pre-primary schools in 1982 to that in 1983?
Offer a terse response. 0.97. What is the ratio of the Gross enrolment ratio (%) in Secondary schools in 1982 to that in 1983?
Make the answer very short. 0.82. What is the ratio of the Gross enrolment ratio (%) of Tertiary schools in 1982 to that in 1983?
Make the answer very short. 1. What is the ratio of the Gross enrolment ratio (%) in Pre-primary schools in 1982 to that in 1984?
Provide a short and direct response. 0.96. What is the ratio of the Gross enrolment ratio (%) in Primary schools in 1982 to that in 1984?
Give a very brief answer. 1. What is the ratio of the Gross enrolment ratio (%) of Secondary schools in 1982 to that in 1984?
Your answer should be very brief. 0.84. What is the ratio of the Gross enrolment ratio (%) in Tertiary schools in 1982 to that in 1984?
Make the answer very short. 0.96. What is the ratio of the Gross enrolment ratio (%) of Pre-primary schools in 1982 to that in 1985?
Your response must be concise. 1.01. What is the ratio of the Gross enrolment ratio (%) of Secondary schools in 1982 to that in 1985?
Your response must be concise. 0.85. What is the ratio of the Gross enrolment ratio (%) in Tertiary schools in 1982 to that in 1985?
Provide a succinct answer. 0.89. What is the ratio of the Gross enrolment ratio (%) in Pre-primary schools in 1982 to that in 1986?
Your response must be concise. 1. What is the ratio of the Gross enrolment ratio (%) in Primary schools in 1982 to that in 1986?
Offer a terse response. 0.98. What is the ratio of the Gross enrolment ratio (%) of Secondary schools in 1982 to that in 1986?
Offer a terse response. 0.89. What is the ratio of the Gross enrolment ratio (%) of Tertiary schools in 1982 to that in 1986?
Your response must be concise. 0.9. What is the ratio of the Gross enrolment ratio (%) of Pre-primary schools in 1982 to that in 1987?
Provide a short and direct response. 1.02. What is the ratio of the Gross enrolment ratio (%) in Primary schools in 1982 to that in 1987?
Your response must be concise. 0.92. What is the ratio of the Gross enrolment ratio (%) of Secondary schools in 1982 to that in 1987?
Your answer should be compact. 0.87. What is the ratio of the Gross enrolment ratio (%) of Tertiary schools in 1982 to that in 1987?
Your answer should be very brief. 0.9. What is the ratio of the Gross enrolment ratio (%) of Pre-primary schools in 1983 to that in 1984?
Your response must be concise. 0.98. What is the ratio of the Gross enrolment ratio (%) of Secondary schools in 1983 to that in 1984?
Your answer should be very brief. 1.03. What is the ratio of the Gross enrolment ratio (%) of Tertiary schools in 1983 to that in 1984?
Your response must be concise. 0.96. What is the ratio of the Gross enrolment ratio (%) of Pre-primary schools in 1983 to that in 1985?
Your response must be concise. 1.04. What is the ratio of the Gross enrolment ratio (%) of Primary schools in 1983 to that in 1985?
Ensure brevity in your answer.  0.99. What is the ratio of the Gross enrolment ratio (%) in Secondary schools in 1983 to that in 1985?
Offer a very short reply. 1.03. What is the ratio of the Gross enrolment ratio (%) in Tertiary schools in 1983 to that in 1985?
Keep it short and to the point. 0.89. What is the ratio of the Gross enrolment ratio (%) in Pre-primary schools in 1983 to that in 1986?
Offer a very short reply. 1.03. What is the ratio of the Gross enrolment ratio (%) in Primary schools in 1983 to that in 1986?
Provide a succinct answer. 0.98. What is the ratio of the Gross enrolment ratio (%) of Secondary schools in 1983 to that in 1986?
Provide a succinct answer. 1.08. What is the ratio of the Gross enrolment ratio (%) of Tertiary schools in 1983 to that in 1986?
Your answer should be very brief. 0.91. What is the ratio of the Gross enrolment ratio (%) in Pre-primary schools in 1983 to that in 1987?
Make the answer very short. 1.05. What is the ratio of the Gross enrolment ratio (%) of Primary schools in 1983 to that in 1987?
Offer a very short reply. 0.91. What is the ratio of the Gross enrolment ratio (%) of Secondary schools in 1983 to that in 1987?
Keep it short and to the point. 1.06. What is the ratio of the Gross enrolment ratio (%) of Tertiary schools in 1983 to that in 1987?
Make the answer very short. 0.9. What is the ratio of the Gross enrolment ratio (%) in Pre-primary schools in 1984 to that in 1985?
Give a very brief answer. 1.05. What is the ratio of the Gross enrolment ratio (%) of Primary schools in 1984 to that in 1985?
Offer a very short reply. 0.99. What is the ratio of the Gross enrolment ratio (%) of Secondary schools in 1984 to that in 1985?
Your answer should be very brief. 1. What is the ratio of the Gross enrolment ratio (%) of Tertiary schools in 1984 to that in 1985?
Offer a terse response. 0.93. What is the ratio of the Gross enrolment ratio (%) of Pre-primary schools in 1984 to that in 1986?
Give a very brief answer. 1.05. What is the ratio of the Gross enrolment ratio (%) in Primary schools in 1984 to that in 1986?
Ensure brevity in your answer.  0.98. What is the ratio of the Gross enrolment ratio (%) of Secondary schools in 1984 to that in 1986?
Provide a succinct answer. 1.05. What is the ratio of the Gross enrolment ratio (%) of Tertiary schools in 1984 to that in 1986?
Offer a terse response. 0.94. What is the ratio of the Gross enrolment ratio (%) in Pre-primary schools in 1984 to that in 1987?
Your response must be concise. 1.07. What is the ratio of the Gross enrolment ratio (%) of Primary schools in 1984 to that in 1987?
Your answer should be very brief. 0.91. What is the ratio of the Gross enrolment ratio (%) in Secondary schools in 1984 to that in 1987?
Make the answer very short. 1.03. What is the ratio of the Gross enrolment ratio (%) of Tertiary schools in 1984 to that in 1987?
Provide a succinct answer. 0.94. What is the ratio of the Gross enrolment ratio (%) in Pre-primary schools in 1985 to that in 1986?
Offer a terse response. 1. What is the ratio of the Gross enrolment ratio (%) of Primary schools in 1985 to that in 1986?
Keep it short and to the point. 0.99. What is the ratio of the Gross enrolment ratio (%) in Secondary schools in 1985 to that in 1986?
Ensure brevity in your answer.  1.05. What is the ratio of the Gross enrolment ratio (%) of Tertiary schools in 1985 to that in 1986?
Keep it short and to the point. 1.02. What is the ratio of the Gross enrolment ratio (%) in Pre-primary schools in 1985 to that in 1987?
Keep it short and to the point. 1.01. What is the ratio of the Gross enrolment ratio (%) in Primary schools in 1985 to that in 1987?
Your answer should be compact. 0.92. What is the ratio of the Gross enrolment ratio (%) in Secondary schools in 1985 to that in 1987?
Provide a succinct answer. 1.03. What is the ratio of the Gross enrolment ratio (%) of Tertiary schools in 1985 to that in 1987?
Ensure brevity in your answer.  1.01. What is the ratio of the Gross enrolment ratio (%) of Primary schools in 1986 to that in 1987?
Give a very brief answer. 0.94. What is the ratio of the Gross enrolment ratio (%) of Secondary schools in 1986 to that in 1987?
Provide a succinct answer. 0.98. What is the difference between the highest and the second highest Gross enrolment ratio (%) in Pre-primary schools?
Provide a short and direct response. 1.63. What is the difference between the highest and the second highest Gross enrolment ratio (%) of Primary schools?
Your answer should be very brief. 7.21. What is the difference between the highest and the second highest Gross enrolment ratio (%) of Secondary schools?
Your answer should be compact. 2.63. What is the difference between the highest and the second highest Gross enrolment ratio (%) of Tertiary schools?
Give a very brief answer. 0.25. What is the difference between the highest and the lowest Gross enrolment ratio (%) in Pre-primary schools?
Your answer should be compact. 6.47. What is the difference between the highest and the lowest Gross enrolment ratio (%) in Primary schools?
Your answer should be compact. 9.79. What is the difference between the highest and the lowest Gross enrolment ratio (%) in Secondary schools?
Provide a short and direct response. 18.53. What is the difference between the highest and the lowest Gross enrolment ratio (%) in Tertiary schools?
Provide a succinct answer. 2.75. 